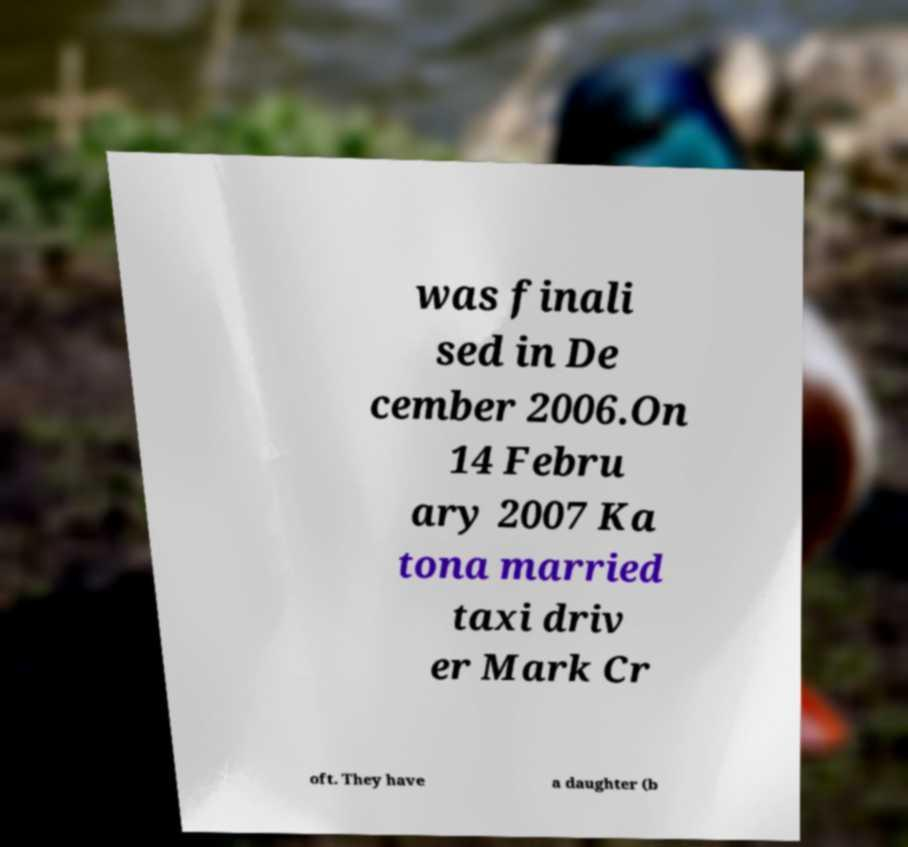Please identify and transcribe the text found in this image. was finali sed in De cember 2006.On 14 Febru ary 2007 Ka tona married taxi driv er Mark Cr oft. They have a daughter (b 